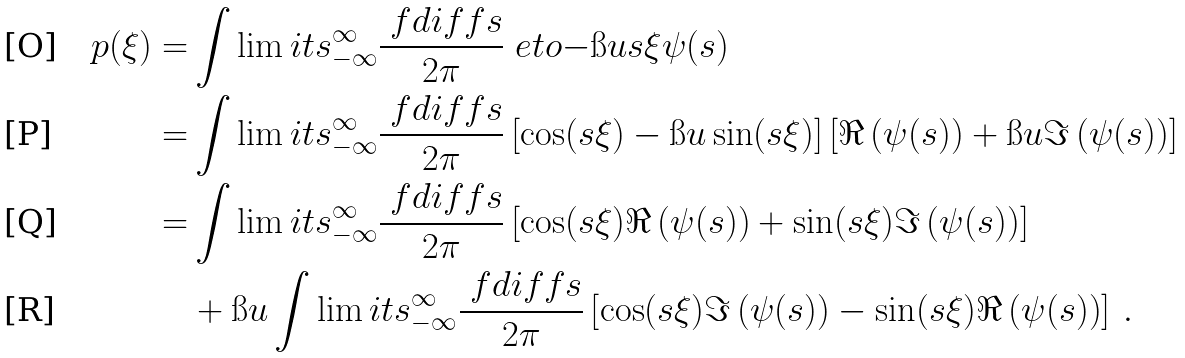<formula> <loc_0><loc_0><loc_500><loc_500>p ( \xi ) = & \int \lim i t s _ { - \infty } ^ { \infty } \frac { \ f d i f f { s } } { 2 \pi } \ e t o { - \i u s \xi } \psi ( s ) \\ = & \int \lim i t s _ { - \infty } ^ { \infty } \frac { \ f d i f f { s } } { 2 \pi } \left [ \cos ( s \xi ) - \i u \sin ( s \xi ) \right ] \left [ \Re \left ( \psi ( s ) \right ) + \i u \Im \left ( \psi ( s ) \right ) \right ] \\ = & \int \lim i t s _ { - \infty } ^ { \infty } \frac { \ f d i f f { s } } { 2 \pi } \left [ \cos ( s \xi ) \Re \left ( \psi ( s ) \right ) + \sin ( s \xi ) \Im \left ( \psi ( s ) \right ) \right ] \\ & + \i u \int \lim i t s _ { - \infty } ^ { \infty } \frac { \ f d i f f { s } } { 2 \pi } \left [ \cos ( s \xi ) \Im \left ( \psi ( s ) \right ) - \sin ( s \xi ) \Re \left ( \psi ( s ) \right ) \right ] \, .</formula> 